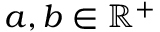Convert formula to latex. <formula><loc_0><loc_0><loc_500><loc_500>a , b \in \mathbb { R } ^ { + }</formula> 